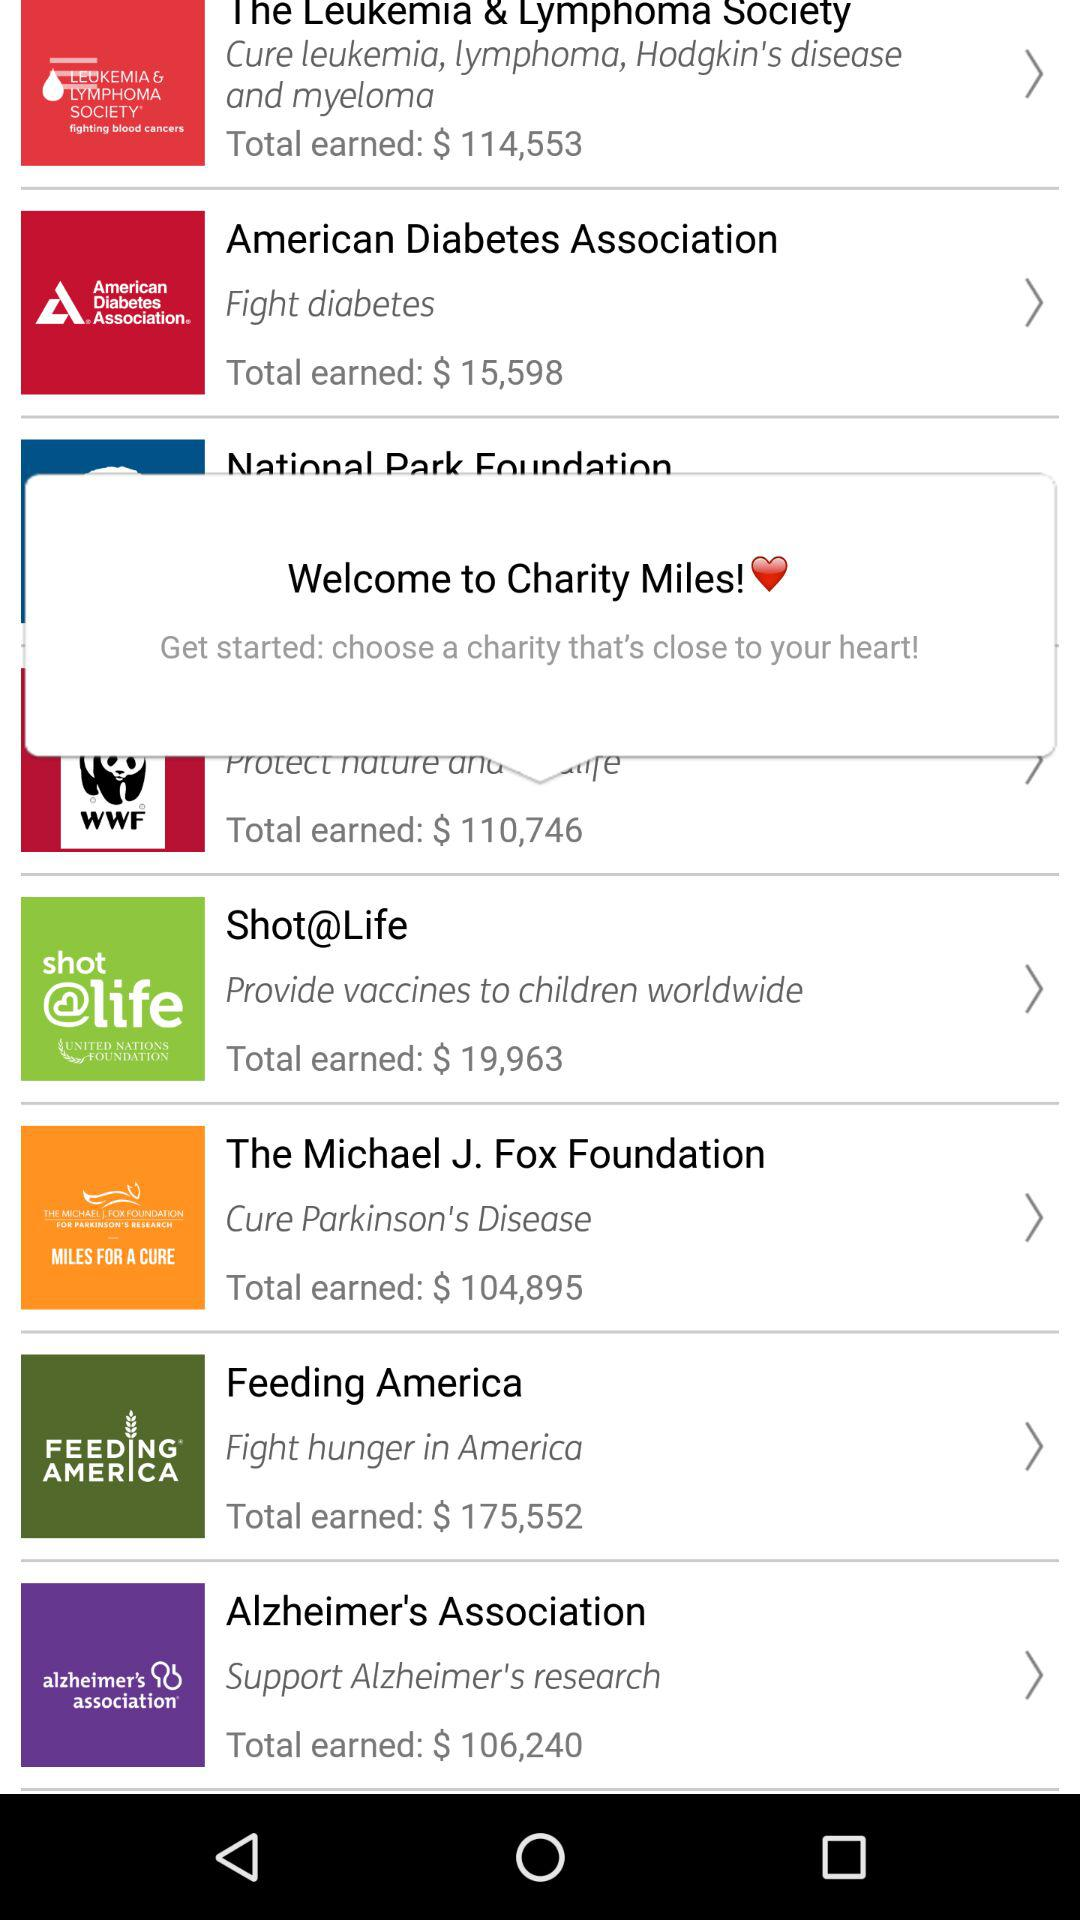Which charity has earned less than $20,000, The Alzheimer's Association or American Diabetes Association?
Answer the question using a single word or phrase. American Diabetes Association 